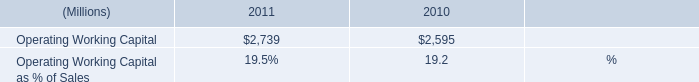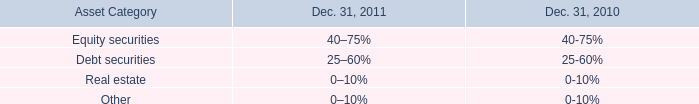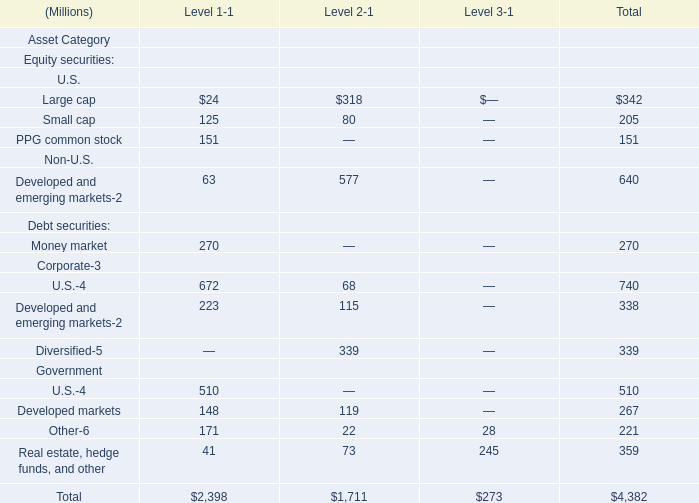In the section with the most Large cap, what is the amount ofSmall cap and PPG common stock ? (in million) 
Computations: (205 + 151)
Answer: 356.0. 